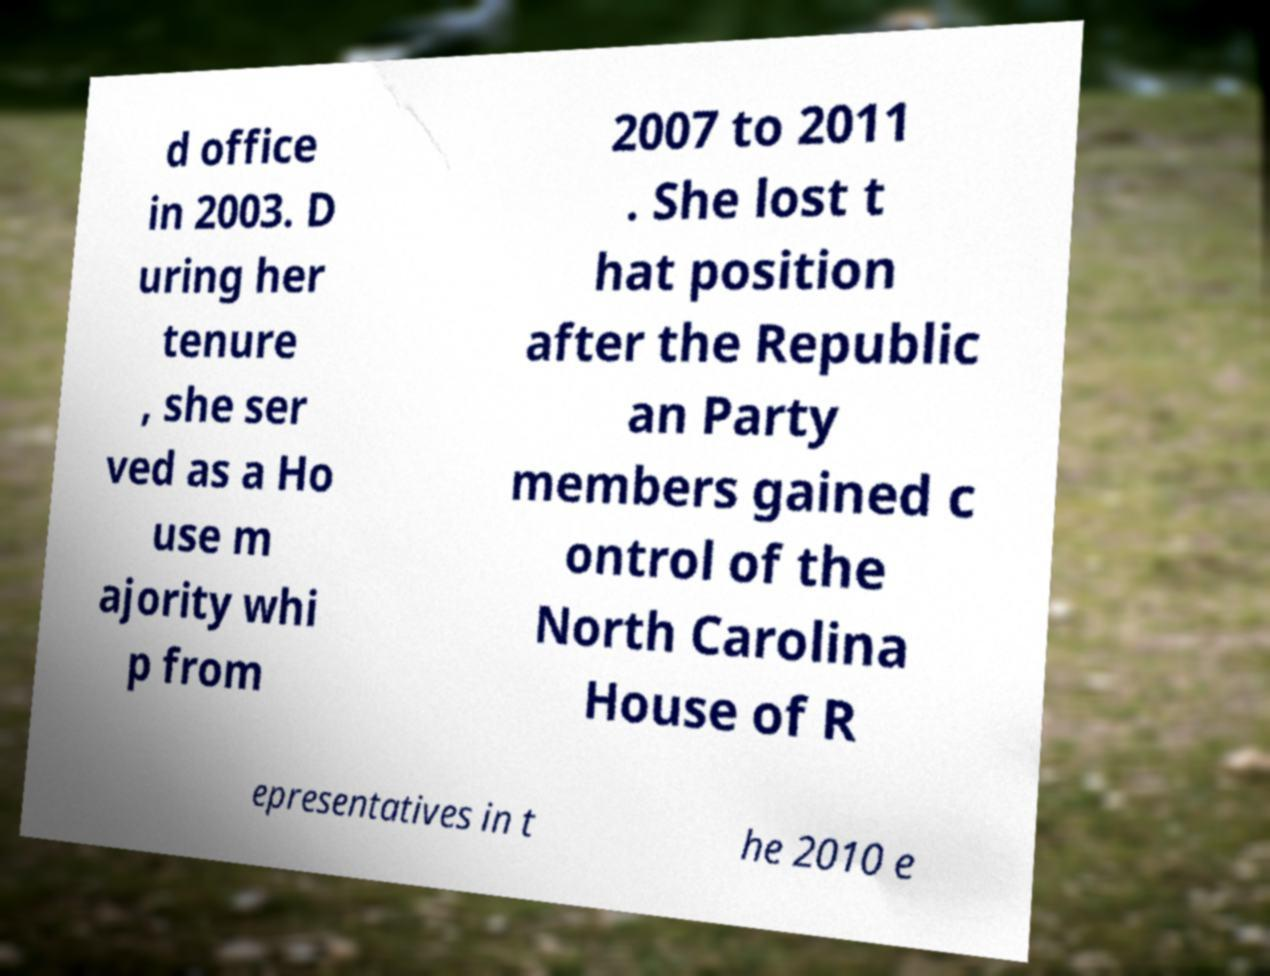Could you extract and type out the text from this image? d office in 2003. D uring her tenure , she ser ved as a Ho use m ajority whi p from 2007 to 2011 . She lost t hat position after the Republic an Party members gained c ontrol of the North Carolina House of R epresentatives in t he 2010 e 